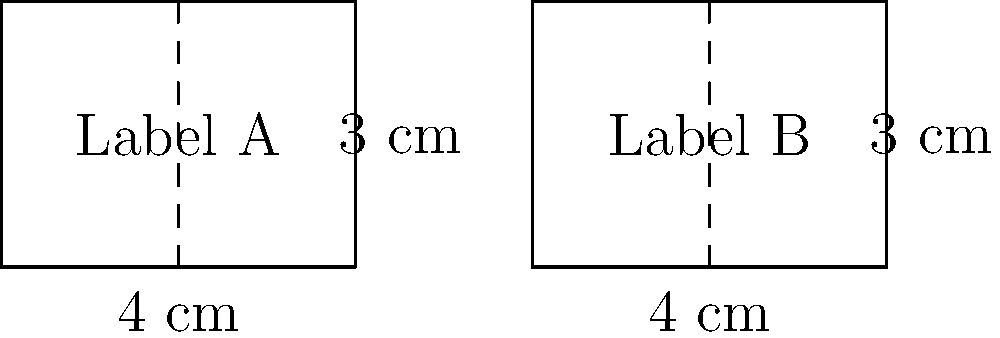You're designing new food safety labels for your freezer items. Two rectangular label designs (Label A and Label B) are shown above. If both labels have the same dimensions, what is the area of each label in square centimeters? To find the area of each label, we need to follow these steps:

1. Identify the shape: Both labels are rectangles.

2. Recall the formula for the area of a rectangle:
   Area = length × width

3. Identify the dimensions:
   Length = 4 cm
   Width = 3 cm

4. Calculate the area:
   Area = 4 cm × 3 cm = 12 cm²

5. Verify congruence:
   Both labels have the same dimensions, so they are congruent and have the same area.

Therefore, each label has an area of 12 square centimeters.
Answer: 12 cm² 